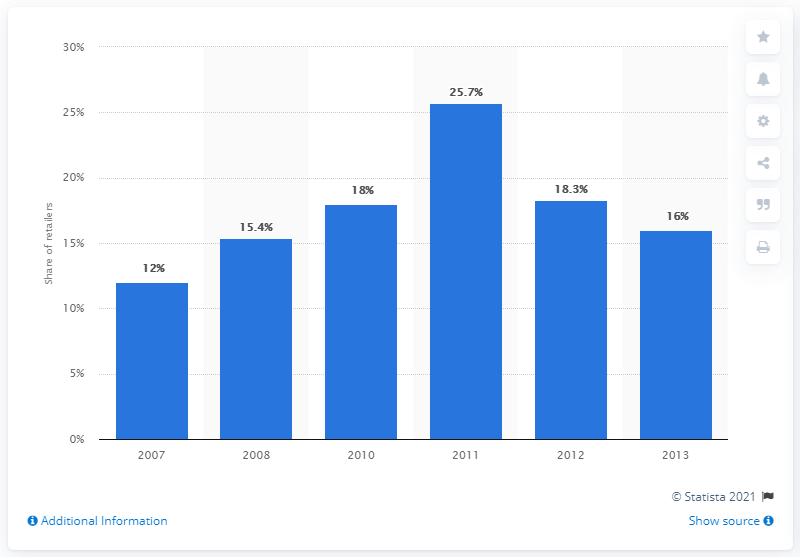List a handful of essential elements in this visual. In 2011, a significant percentage of online retailers offered gift wrapping services. Specifically, 25.7% of online retailers provided this option to their customers. In 2013, 16% of retailers offered gift wrapping services. 